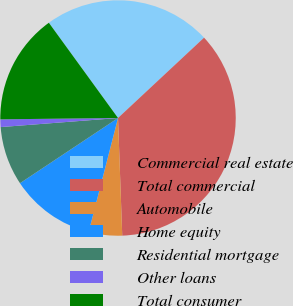Convert chart to OTSL. <chart><loc_0><loc_0><loc_500><loc_500><pie_chart><fcel>Commercial real estate<fcel>Total commercial<fcel>Automobile<fcel>Home equity<fcel>Residential mortgage<fcel>Other loans<fcel>Total consumer<nl><fcel>23.04%<fcel>36.38%<fcel>4.58%<fcel>11.65%<fcel>8.11%<fcel>1.05%<fcel>15.18%<nl></chart> 